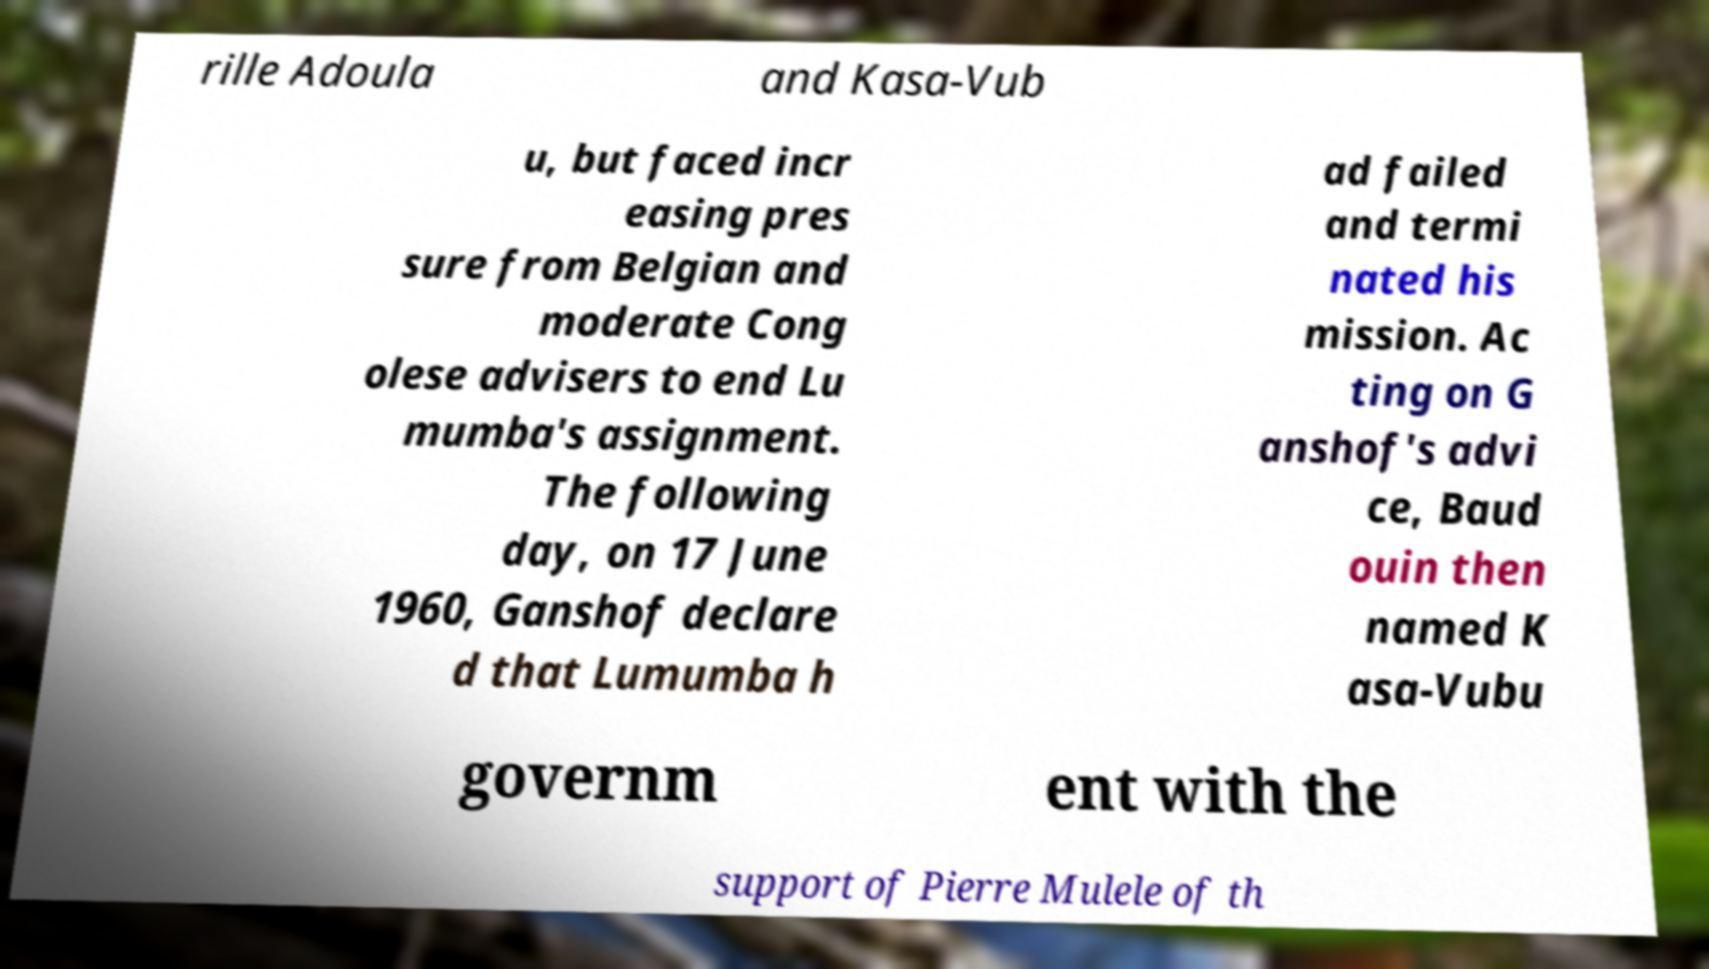Could you extract and type out the text from this image? rille Adoula and Kasa-Vub u, but faced incr easing pres sure from Belgian and moderate Cong olese advisers to end Lu mumba's assignment. The following day, on 17 June 1960, Ganshof declare d that Lumumba h ad failed and termi nated his mission. Ac ting on G anshof's advi ce, Baud ouin then named K asa-Vubu governm ent with the support of Pierre Mulele of th 